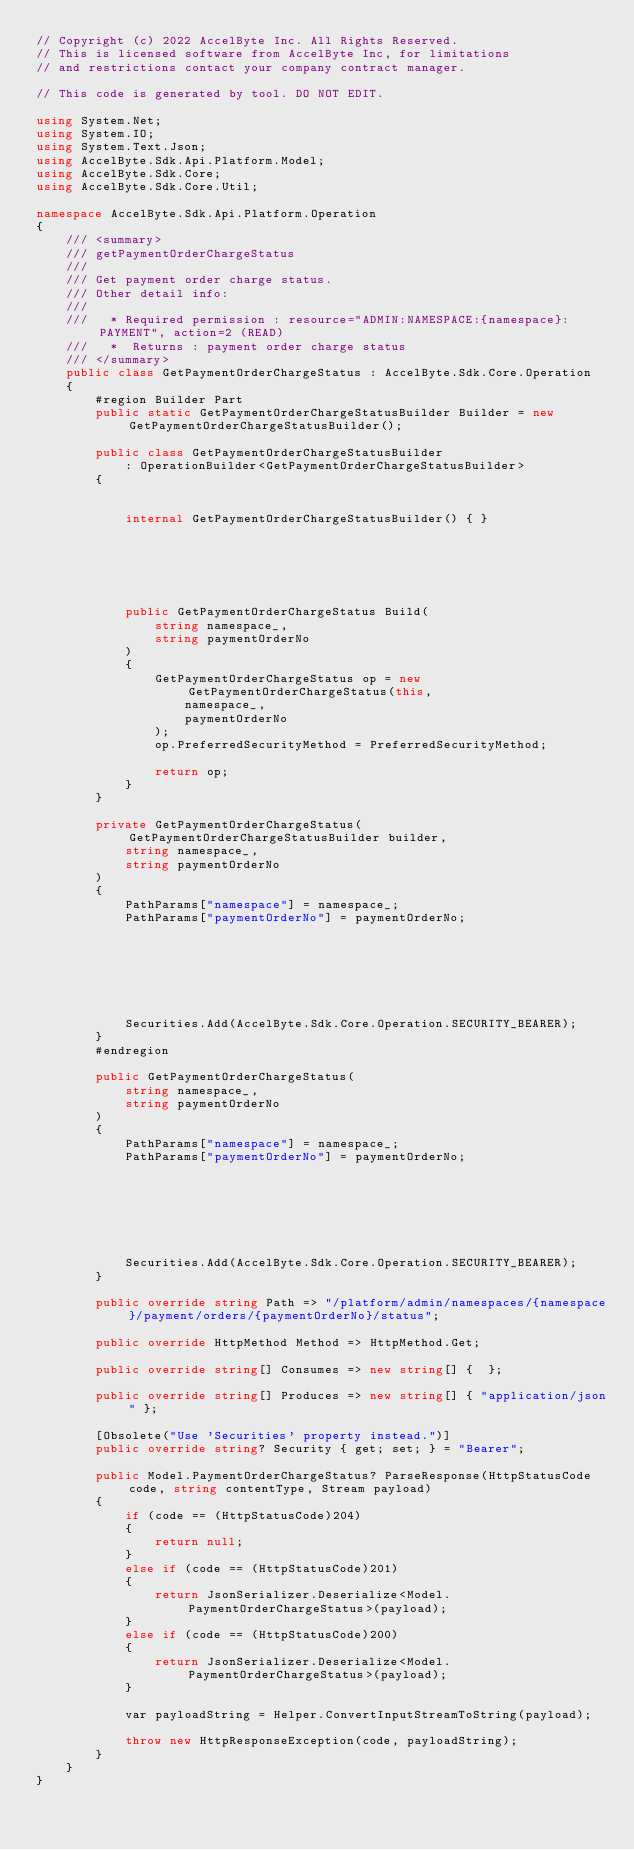<code> <loc_0><loc_0><loc_500><loc_500><_C#_>// Copyright (c) 2022 AccelByte Inc. All Rights Reserved.
// This is licensed software from AccelByte Inc, for limitations
// and restrictions contact your company contract manager.

// This code is generated by tool. DO NOT EDIT.

using System.Net;
using System.IO;
using System.Text.Json;
using AccelByte.Sdk.Api.Platform.Model;
using AccelByte.Sdk.Core;
using AccelByte.Sdk.Core.Util;

namespace AccelByte.Sdk.Api.Platform.Operation
{
    /// <summary>
    /// getPaymentOrderChargeStatus
    ///
    /// Get payment order charge status.
    /// Other detail info:
    /// 
    ///   * Required permission : resource="ADMIN:NAMESPACE:{namespace}:PAYMENT", action=2 (READ)
    ///   *  Returns : payment order charge status
    /// </summary>
    public class GetPaymentOrderChargeStatus : AccelByte.Sdk.Core.Operation
    {
        #region Builder Part
        public static GetPaymentOrderChargeStatusBuilder Builder = new GetPaymentOrderChargeStatusBuilder();

        public class GetPaymentOrderChargeStatusBuilder
            : OperationBuilder<GetPaymentOrderChargeStatusBuilder>
        {
            
            
            internal GetPaymentOrderChargeStatusBuilder() { }






            public GetPaymentOrderChargeStatus Build(
                string namespace_,
                string paymentOrderNo
            )
            {
                GetPaymentOrderChargeStatus op = new GetPaymentOrderChargeStatus(this,
                    namespace_,                    
                    paymentOrderNo                    
                );
                op.PreferredSecurityMethod = PreferredSecurityMethod;

                return op;
            }
        }

        private GetPaymentOrderChargeStatus(GetPaymentOrderChargeStatusBuilder builder,
            string namespace_,
            string paymentOrderNo
        )
        {
            PathParams["namespace"] = namespace_;
            PathParams["paymentOrderNo"] = paymentOrderNo;
            
            

            
            
            

            Securities.Add(AccelByte.Sdk.Core.Operation.SECURITY_BEARER);
        }
        #endregion

        public GetPaymentOrderChargeStatus(
            string namespace_,            
            string paymentOrderNo            
        )
        {
            PathParams["namespace"] = namespace_;
            PathParams["paymentOrderNo"] = paymentOrderNo;
            
            

            
            
            

            Securities.Add(AccelByte.Sdk.Core.Operation.SECURITY_BEARER);
        }

        public override string Path => "/platform/admin/namespaces/{namespace}/payment/orders/{paymentOrderNo}/status";

        public override HttpMethod Method => HttpMethod.Get;

        public override string[] Consumes => new string[] {  };

        public override string[] Produces => new string[] { "application/json" };

        [Obsolete("Use 'Securities' property instead.")]
        public override string? Security { get; set; } = "Bearer";
        
        public Model.PaymentOrderChargeStatus? ParseResponse(HttpStatusCode code, string contentType, Stream payload)
        {            
            if (code == (HttpStatusCode)204)
            {
                return null;
            }
            else if (code == (HttpStatusCode)201)
            {
                return JsonSerializer.Deserialize<Model.PaymentOrderChargeStatus>(payload);
            }
            else if (code == (HttpStatusCode)200)
            {
                return JsonSerializer.Deserialize<Model.PaymentOrderChargeStatus>(payload);
            }
            
            var payloadString = Helper.ConvertInputStreamToString(payload);
            
            throw new HttpResponseException(code, payloadString);
        }
    }
}</code> 